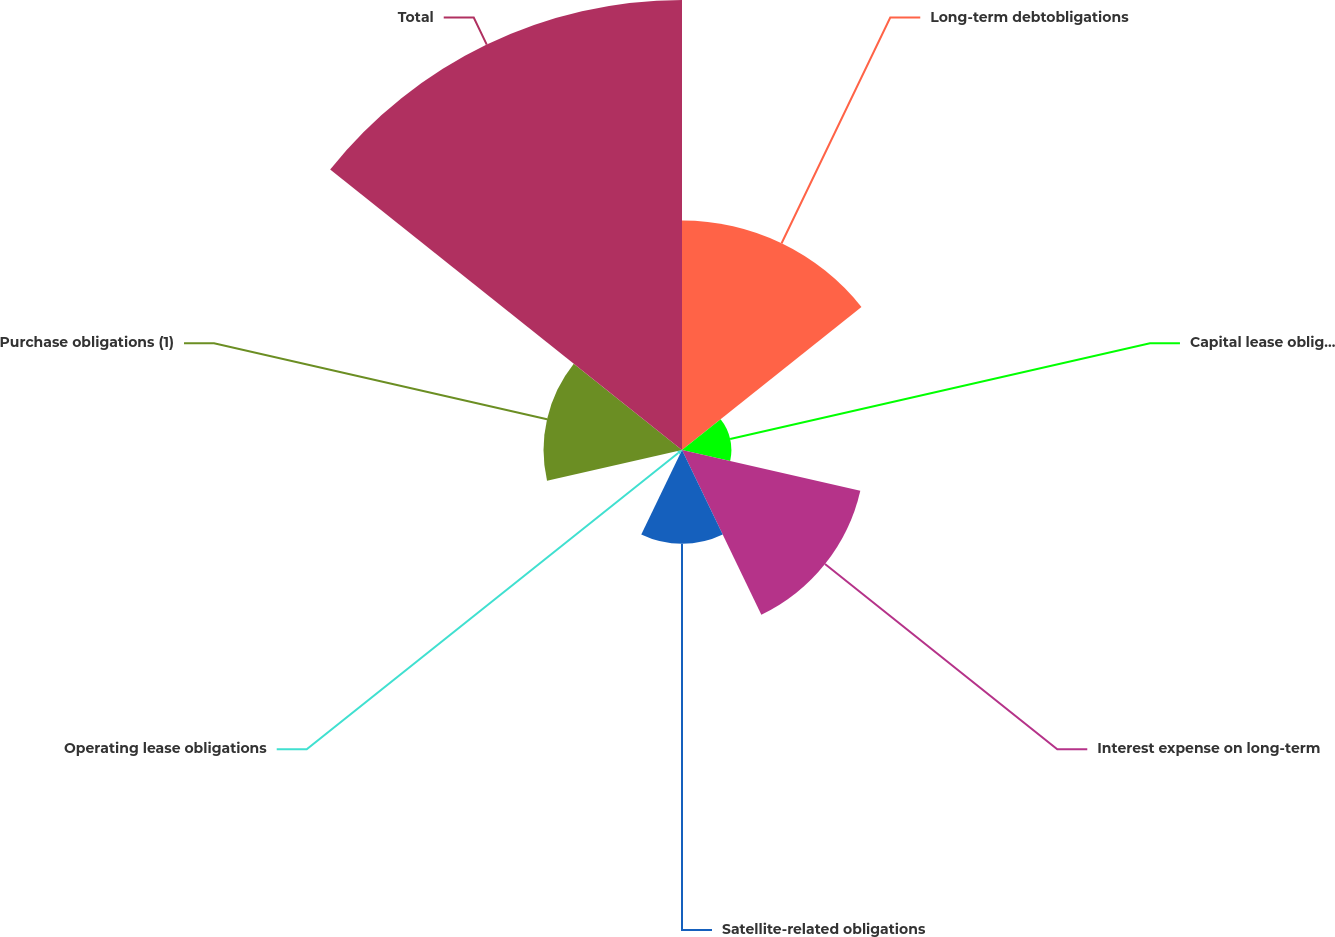<chart> <loc_0><loc_0><loc_500><loc_500><pie_chart><fcel>Long-term debtobligations<fcel>Capital lease obligations<fcel>Interest expense on long-term<fcel>Satellite-related obligations<fcel>Operating lease obligations<fcel>Purchase obligations (1)<fcel>Total<nl><fcel>19.98%<fcel>4.3%<fcel>15.92%<fcel>8.17%<fcel>0.42%<fcel>12.05%<fcel>39.17%<nl></chart> 